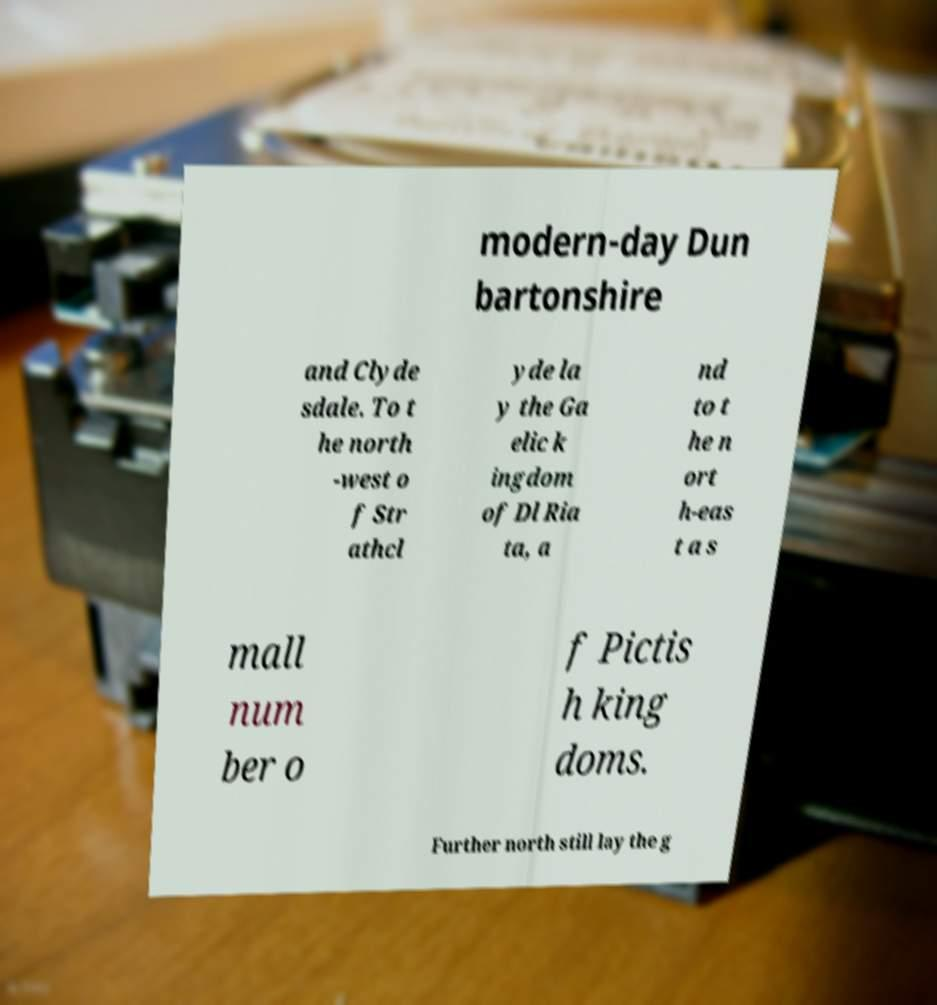Can you read and provide the text displayed in the image?This photo seems to have some interesting text. Can you extract and type it out for me? modern-day Dun bartonshire and Clyde sdale. To t he north -west o f Str athcl yde la y the Ga elic k ingdom of Dl Ria ta, a nd to t he n ort h-eas t a s mall num ber o f Pictis h king doms. Further north still lay the g 